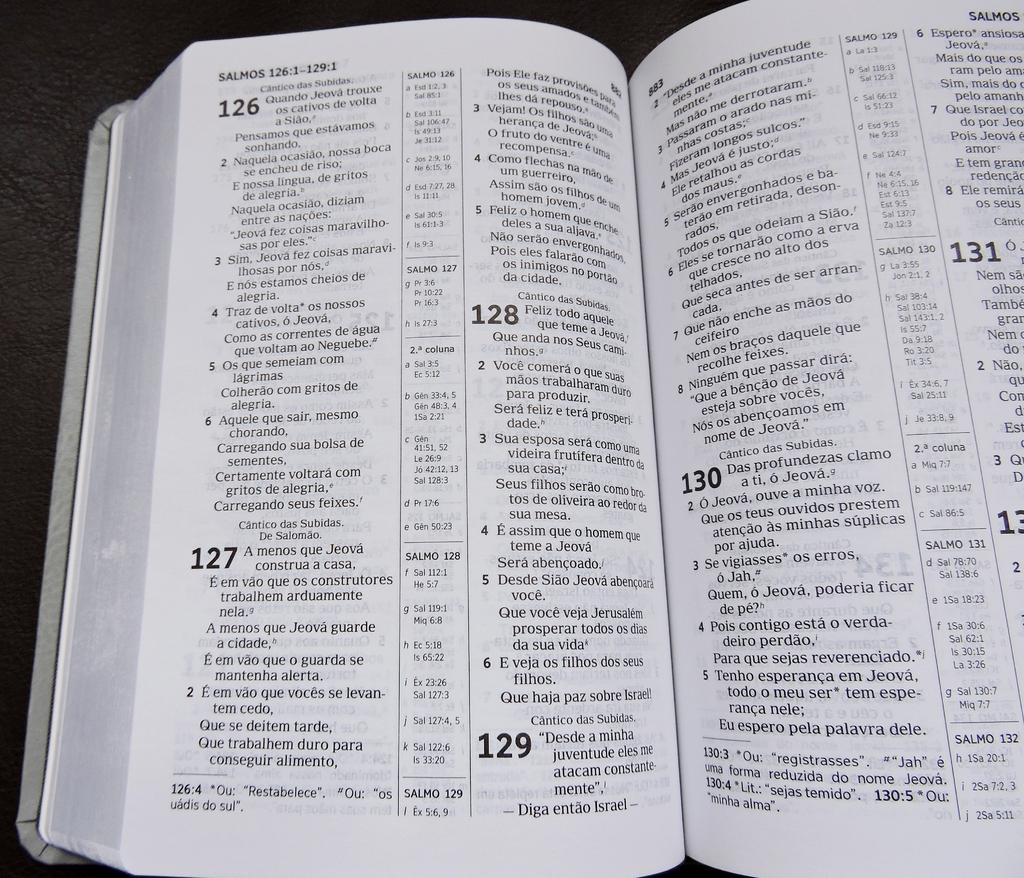<image>
Describe the image concisely. A book is opened to the Salmos chapter. 